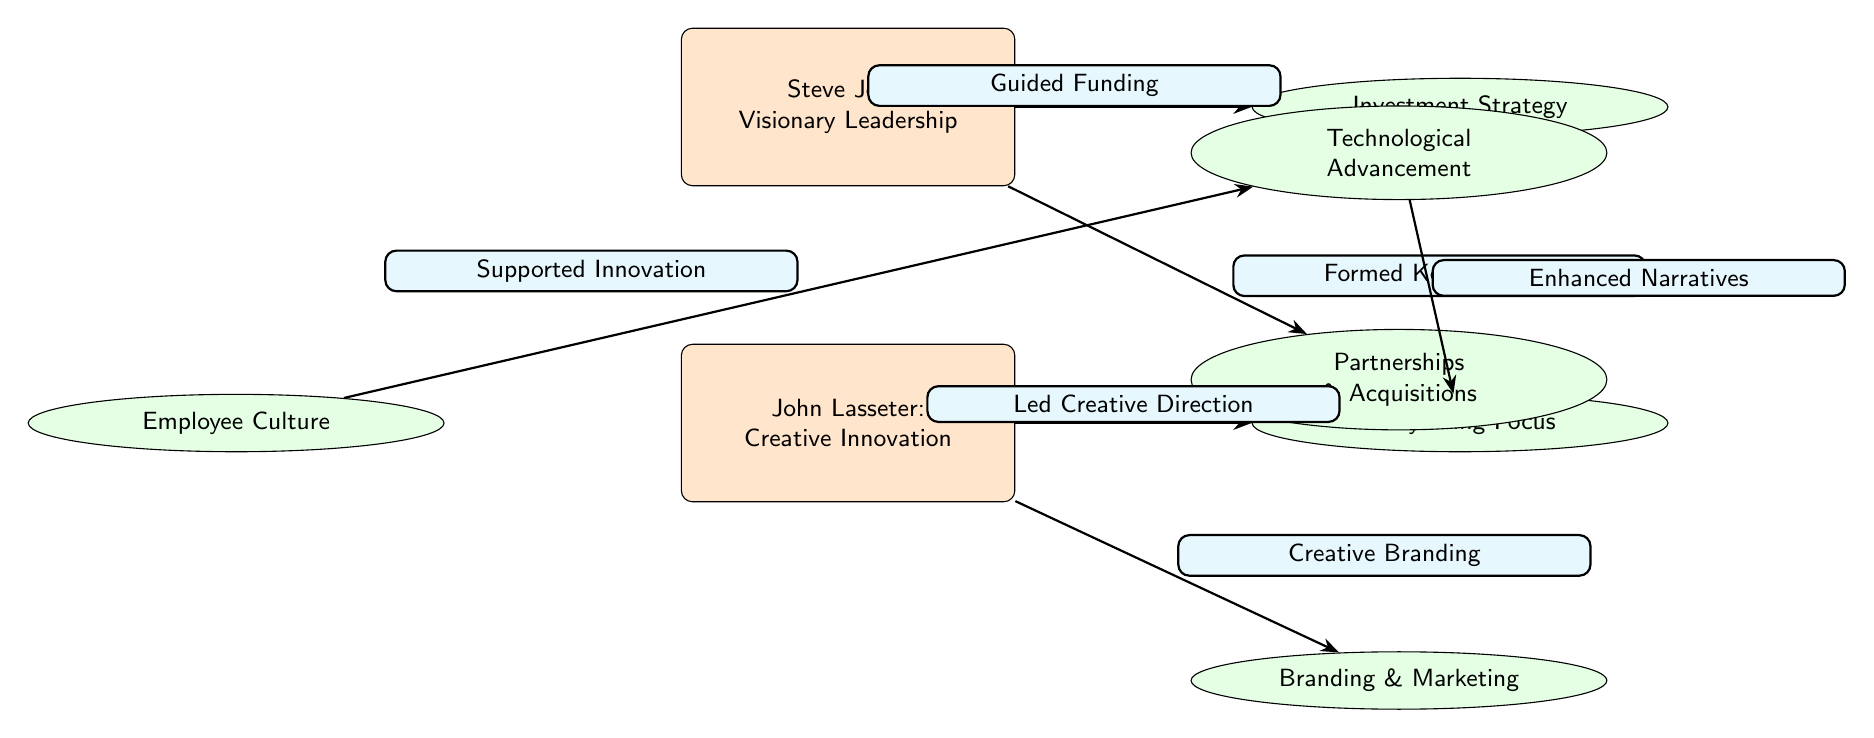What is the primary focus of John Lasseter's strategy? In the diagram, John Lasseter is associated with the node labeled "Storytelling Focus." This indicates that his primary strategic focus is storytelling.
Answer: Storytelling Focus How many leaders are represented in the diagram? The diagram has two leader nodes: Steve Jobs and John Lasseter. Thus, counting these nodes gives us the total number.
Answer: 2 What strategy is linked to Steve Jobs via "Guided Funding"? The strategy linked to Steve Jobs via the edge labeled "Guided Funding" is "Investment Strategy," which is shown as one of the strategies branching from Jobs.
Answer: Investment Strategy Which strategy is supported by the "Employee Culture"? The diagram shows an edge from "Employee Culture" to "Technological Advancement," indicating that Employee Culture supports Technological Advancement.
Answer: Technological Advancement What type of leadership is associated with Steve Jobs? The diagram labels Steve Jobs's leadership as "Visionary Leadership." This node provides a clear description of the type of leadership he represents.
Answer: Visionary Leadership How is the strategy "Creative Branding" connected to John Lasseter? The node "Creative Branding" is directly linked to John Lasseter by an edge labeled "Creative Branding." This connection highlights how branding is part of Lasseter's strategies.
Answer: Creative Branding What is the relationship between "Technology Advancement" and "Storytelling Focus"? "Technology Advancement" is connected to "Storytelling Focus" through an edge labeled "Enhanced Narratives," indicating that advancements in technology enhance storytelling methods within Pixar's business strategies.
Answer: Enhanced Narratives What strategy was formed by Steve Jobs through partnerships? The strategy related to partnerships formed by Steve Jobs is labeled "Partnerships & Acquisitions," showing how strategic partnerships played a role in his overall business approach.
Answer: Partnerships & Acquisitions 